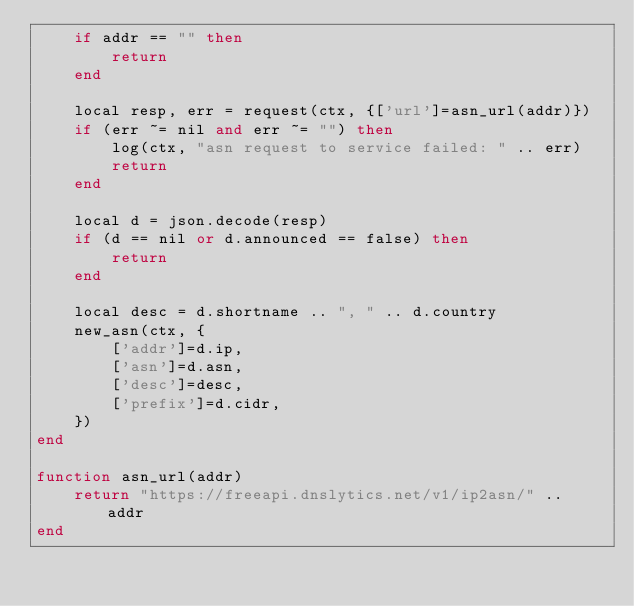<code> <loc_0><loc_0><loc_500><loc_500><_Ada_>    if addr == "" then
        return
    end

    local resp, err = request(ctx, {['url']=asn_url(addr)})
    if (err ~= nil and err ~= "") then
        log(ctx, "asn request to service failed: " .. err)
        return
    end

    local d = json.decode(resp)
    if (d == nil or d.announced == false) then
        return
    end

    local desc = d.shortname .. ", " .. d.country
    new_asn(ctx, {
        ['addr']=d.ip,
        ['asn']=d.asn,
        ['desc']=desc,
        ['prefix']=d.cidr,
    })
end

function asn_url(addr)
    return "https://freeapi.dnslytics.net/v1/ip2asn/" .. addr
end
</code> 